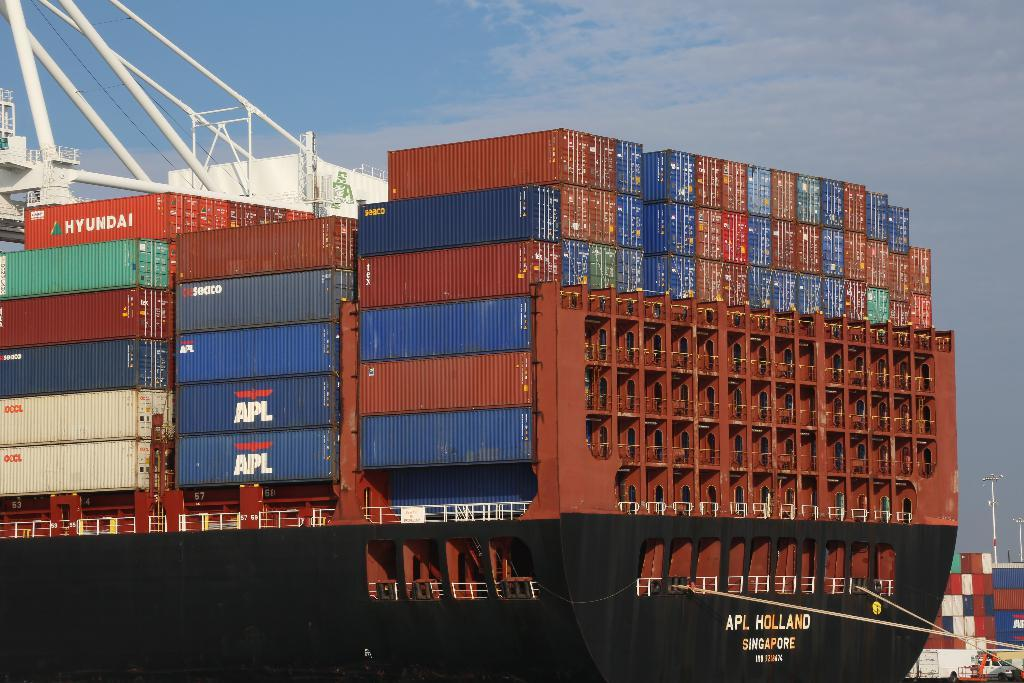What is the main subject of the image? The main subject of the image is a group of containers. Where are the containers located? The containers are on a platform. What can be seen in the background of the image? The sky is visible in the background of the image. What type of print can be seen on the containers in the image? There is no print visible on the containers in the image. Can you tell me how many people are smiling in the image? There are no people present in the image, so it is not possible to determine how many are smiling. 